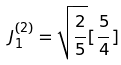<formula> <loc_0><loc_0><loc_500><loc_500>J _ { 1 } ^ { ( 2 ) } = \sqrt { \frac { 2 } { 5 } } [ \frac { 5 } { 4 } ]</formula> 